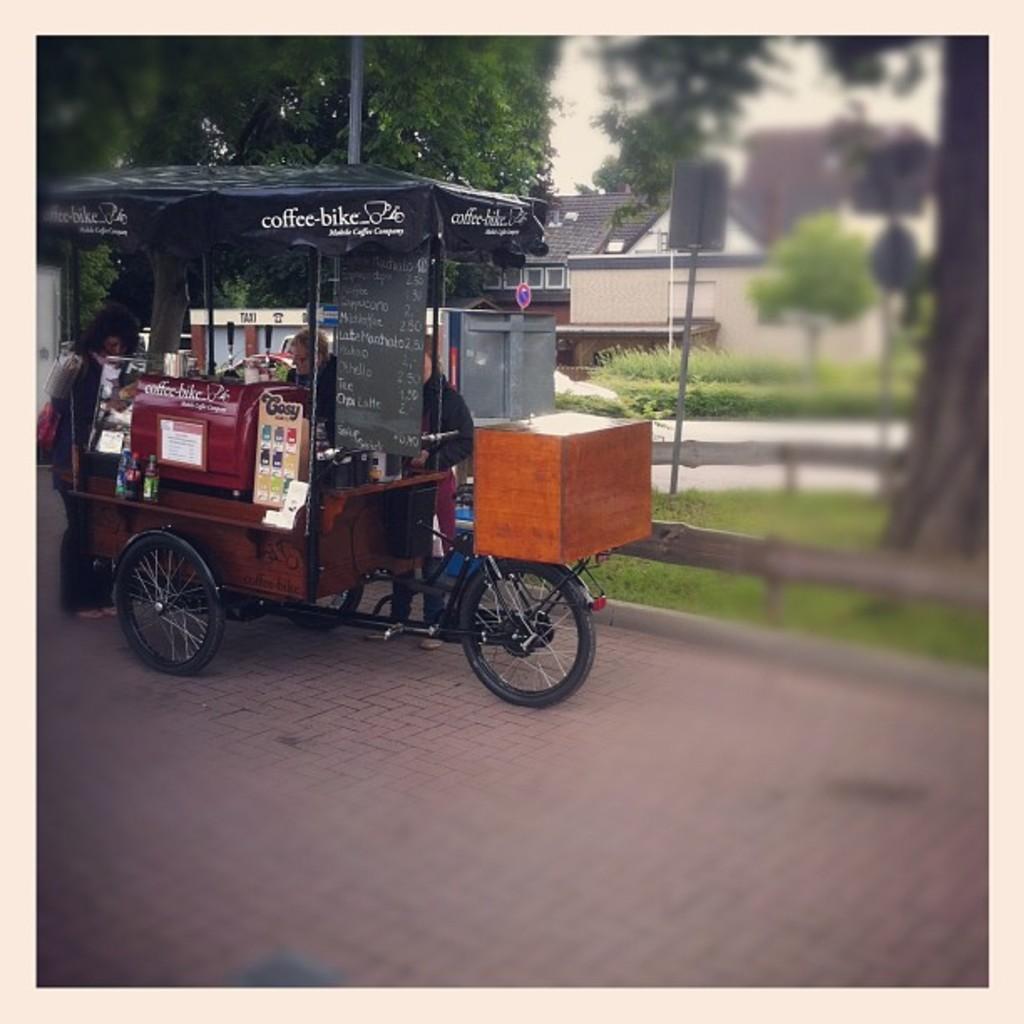In one or two sentences, can you explain what this image depicts? In this image we can see a vehicle which is placed on the ground containing a board with some text, some objects, a tent and a container in it. We can also see some people standing around it. On the backside we can see a wooden pole, some grass, a house, a board to a pole, a group of trees, a pole and the sky. 